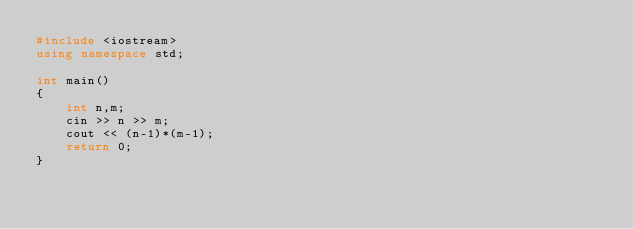Convert code to text. <code><loc_0><loc_0><loc_500><loc_500><_C++_>#include <iostream>
using namespace std;

int main()
{
    int n,m;
    cin >> n >> m;
    cout << (n-1)*(m-1);
    return 0;
}</code> 